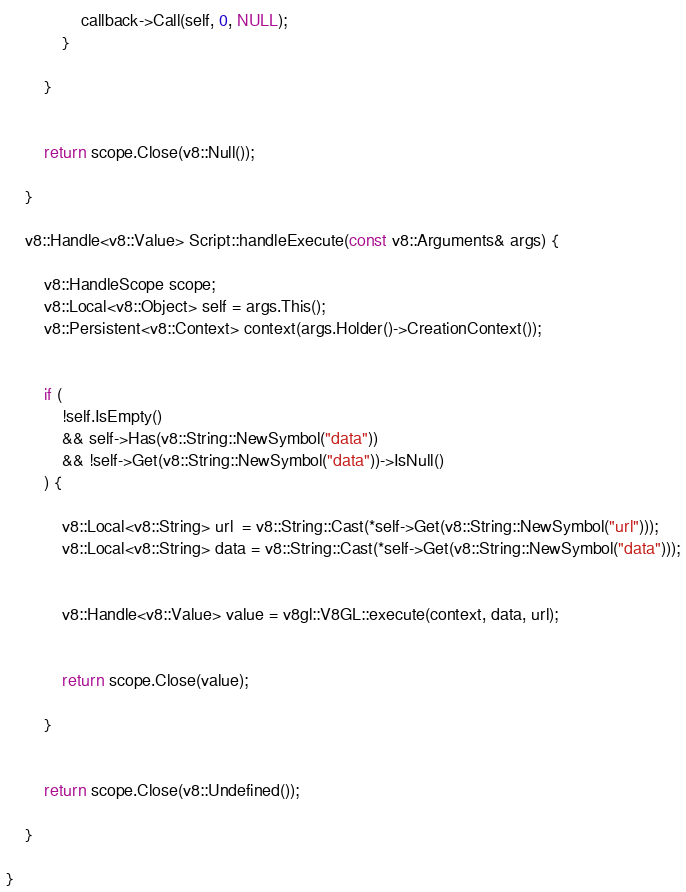<code> <loc_0><loc_0><loc_500><loc_500><_C++_>				callback->Call(self, 0, NULL);
			}

		}


		return scope.Close(v8::Null());

	}

	v8::Handle<v8::Value> Script::handleExecute(const v8::Arguments& args) {

		v8::HandleScope scope;
		v8::Local<v8::Object> self = args.This();
		v8::Persistent<v8::Context> context(args.Holder()->CreationContext());


		if (
			!self.IsEmpty()
			&& self->Has(v8::String::NewSymbol("data"))
			&& !self->Get(v8::String::NewSymbol("data"))->IsNull()
		) {

			v8::Local<v8::String> url  = v8::String::Cast(*self->Get(v8::String::NewSymbol("url")));
			v8::Local<v8::String> data = v8::String::Cast(*self->Get(v8::String::NewSymbol("data")));


			v8::Handle<v8::Value> value = v8gl::V8GL::execute(context, data, url);


			return scope.Close(value);

		}


		return scope.Close(v8::Undefined());

	}

}

</code> 